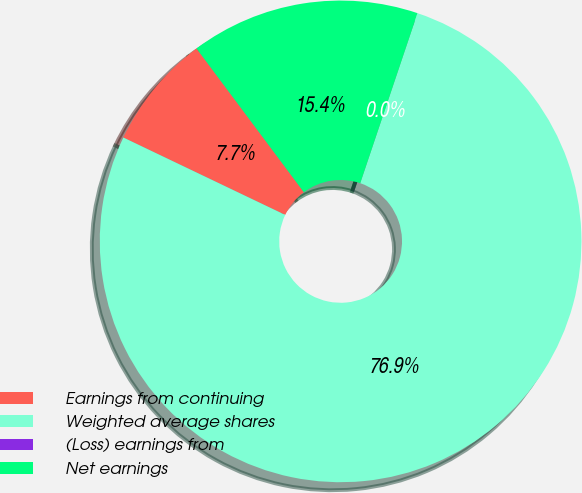Convert chart to OTSL. <chart><loc_0><loc_0><loc_500><loc_500><pie_chart><fcel>Earnings from continuing<fcel>Weighted average shares<fcel>(Loss) earnings from<fcel>Net earnings<nl><fcel>7.69%<fcel>76.92%<fcel>0.0%<fcel>15.38%<nl></chart> 